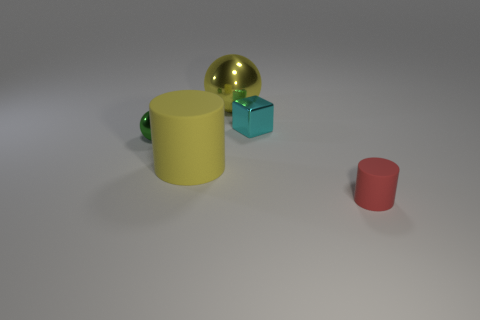How many other things are the same color as the block?
Your answer should be very brief. 0. There is a shiny thing that is behind the tiny cyan block; what is its color?
Provide a succinct answer. Yellow. How many other things are there of the same material as the red thing?
Provide a short and direct response. 1. Are there more shiny cubes behind the big ball than cyan metal blocks right of the tiny cylinder?
Provide a succinct answer. No. There is a big yellow metal object; what number of large cylinders are to the right of it?
Provide a short and direct response. 0. Is the material of the small red cylinder the same as the big yellow object that is in front of the tiny sphere?
Your answer should be compact. Yes. Is there anything else that has the same shape as the small cyan thing?
Make the answer very short. No. Is the material of the tiny cylinder the same as the yellow ball?
Provide a short and direct response. No. There is a cylinder left of the tiny rubber object; are there any small green metal objects that are on the left side of it?
Keep it short and to the point. Yes. What number of things are both behind the big cylinder and on the right side of the green object?
Give a very brief answer. 2. 